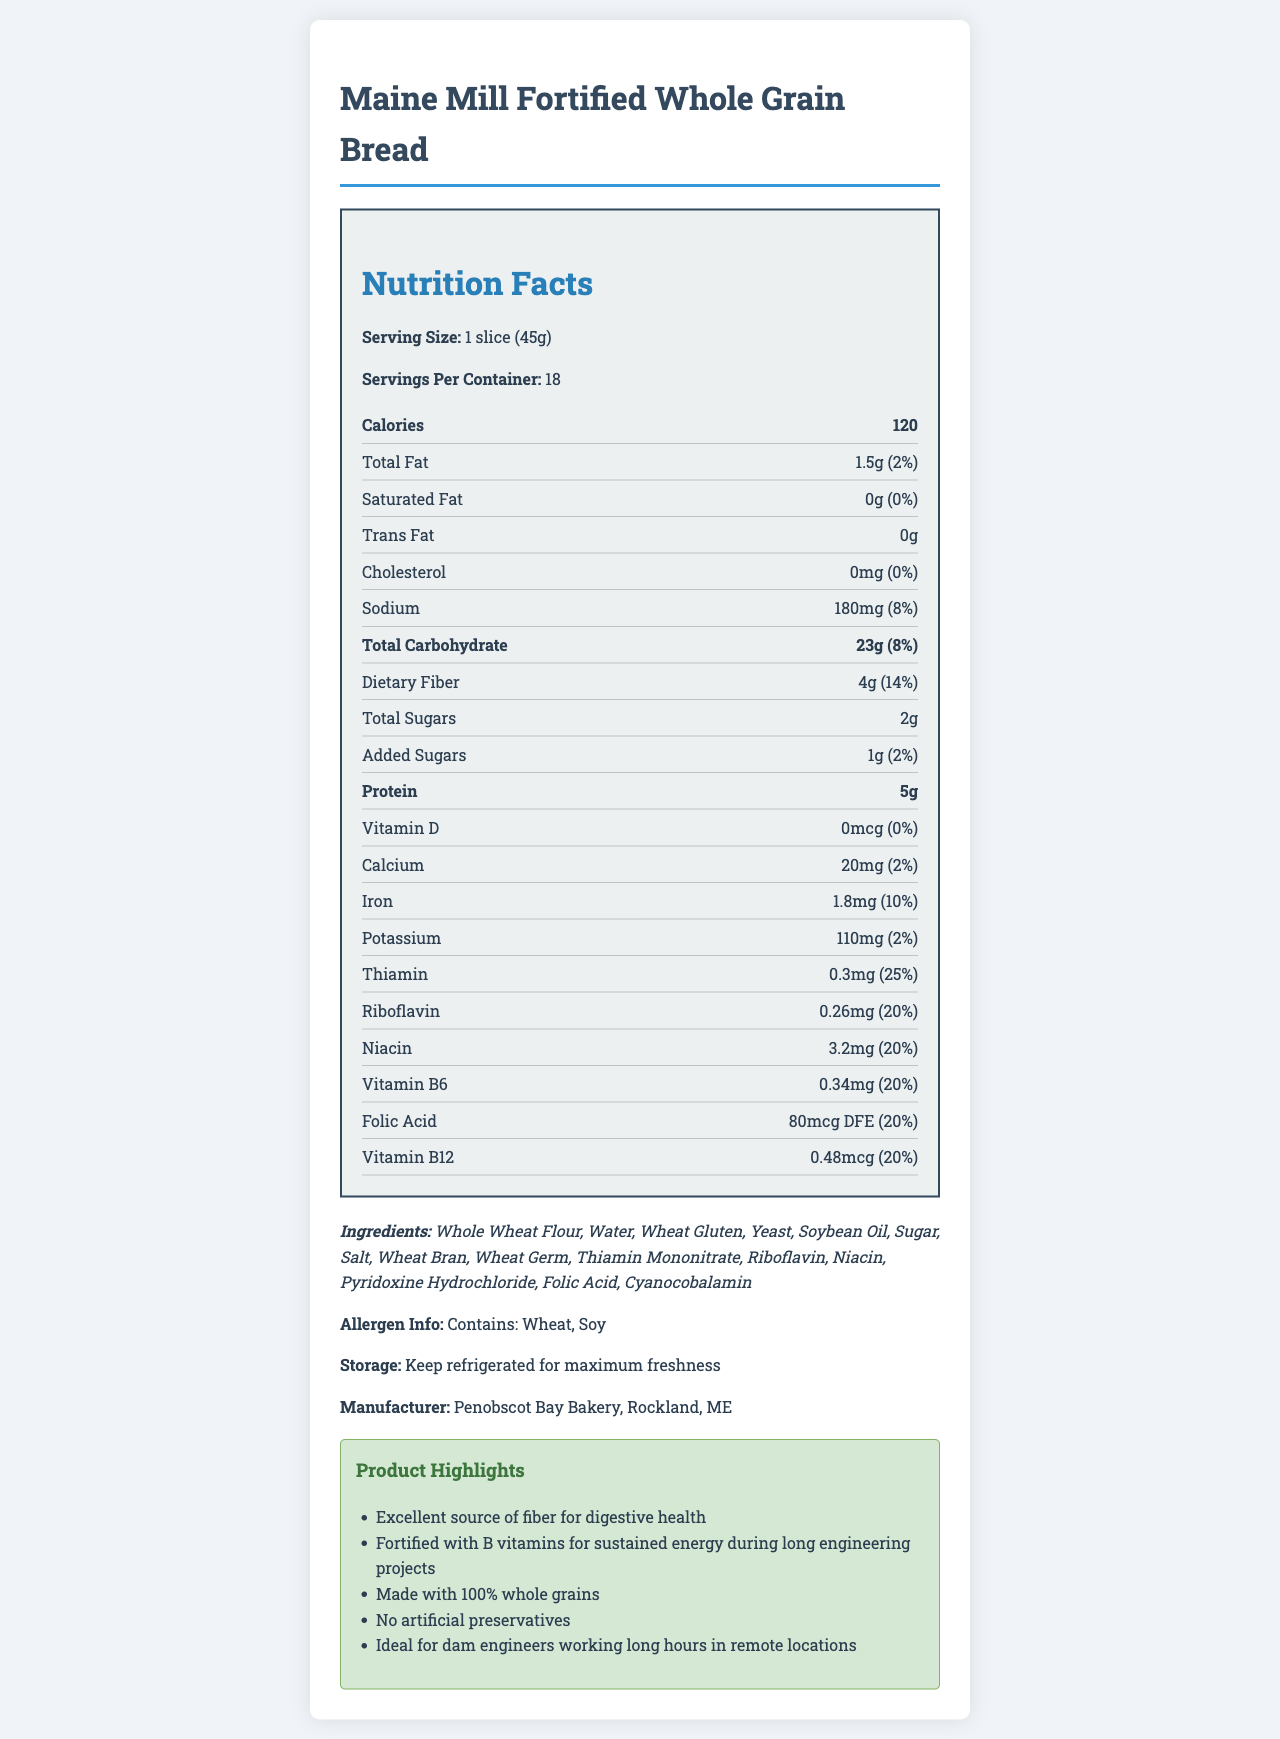how many servings are in the container? The document states that there are 18 servings per container.
Answer: 18 what is the serving size of the Maine Mill Fortified Whole Grain Bread? The document indicates that the serving size is 1 slice (45g).
Answer: 1 slice (45g) how many calories are in one serving of the bread? The document specifies that there are 120 calories per serving.
Answer: 120 what is the amount of dietary fiber in one slice of the bread? According to the nutrition label, one slice contains 4g of dietary fiber.
Answer: 4g what percentage of daily value for thiamin does one serving of the bread provide? The document states that one serving provides 25% of the daily value for thiamin.
Answer: 25% how much protein is in one slice of the bread? The nutrition label shows that one slice contains 5g of protein.
Answer: 5g what is the cholesterol content in one slice of the bread? A. 0mg B. 5mg C. 10mg D. 15mg The document states that one slice of the bread contains 0mg of cholesterol.
Answer: A. 0mg which of the following is NOT an ingredient in the bread? A. Whole Wheat Flour B. Sugar C. Corn Syrup D. Yeast The ingredient list does not include corn syrup; it lists Whole Wheat Flour, Sugar, and Yeast among others.
Answer: C. Corn Syrup does the bread contain any artificial preservatives? The marketing claims state that the bread contains no artificial preservatives.
Answer: No summarize the main features of the Maine Mill Fortified Whole Grain Bread. This response summarizes the nutritional content, main ingredients, key features highlighted in the marketing claims, and the specific benefits for the target audience of engineers.
Answer: The Maine Mill Fortified Whole Grain Bread is a high-fiber, whole grain bread fortified with B vitamins. It has a serving size of 1 slice (45g) with 120 calories per serving. It contains 4g of dietary fiber, 5g of protein, and significant percentages of daily values for B vitamins such as thiamin (25%), riboflavin (20%), niacin (20%), vitamin B6 (20%), folic acid (20%), and vitamin B12 (20%). It is made with 100% whole grains, contains no artificial preservatives, and is ideal for individuals in demanding professions, such as dam engineers, due to its sustained energy benefits. what is the purpose of "thiamin mononitrate" in the ingredients list? The document lists thiamin mononitrate as an ingredient but does not provide the purpose or function of it.
Answer: Not enough information 